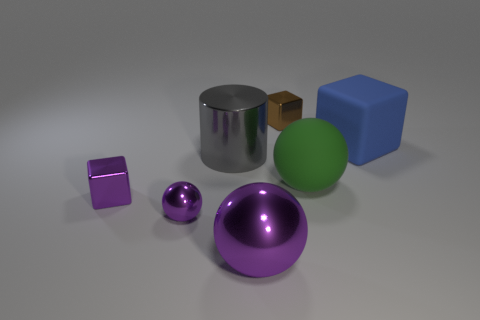How big is the matte thing that is behind the matte object that is in front of the blue cube to the right of the cylinder?
Provide a short and direct response. Large. There is a cube that is both on the left side of the large rubber cube and behind the big green rubber ball; what size is it?
Your response must be concise. Small. Is the color of the tiny shiny cube on the left side of the brown metal cube the same as the big metal thing that is in front of the matte ball?
Provide a short and direct response. Yes. There is a big green matte object; how many big metallic spheres are to the right of it?
Offer a very short reply. 0. There is a purple shiny sphere behind the sphere in front of the small purple shiny ball; is there a small purple metallic ball that is behind it?
Provide a short and direct response. No. What number of rubber blocks have the same size as the gray object?
Keep it short and to the point. 1. The tiny block that is to the left of the metallic thing that is behind the big blue cube is made of what material?
Offer a very short reply. Metal. There is a large green matte thing that is right of the tiny cube that is behind the large cylinder on the right side of the purple shiny cube; what is its shape?
Your answer should be compact. Sphere. Does the small thing behind the green ball have the same shape as the large metallic object behind the green matte ball?
Keep it short and to the point. No. How many other things are the same material as the big purple thing?
Provide a short and direct response. 4. 